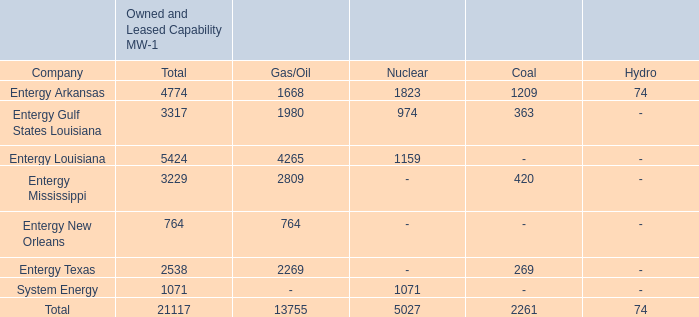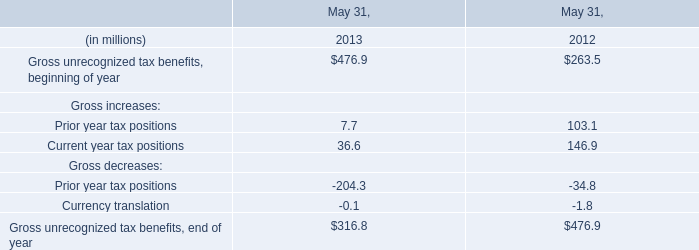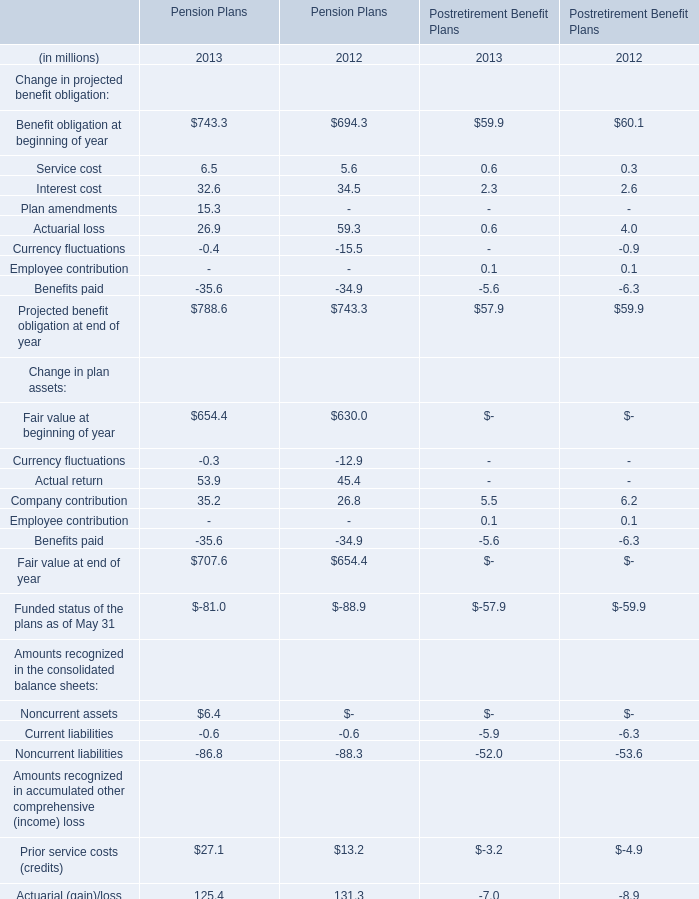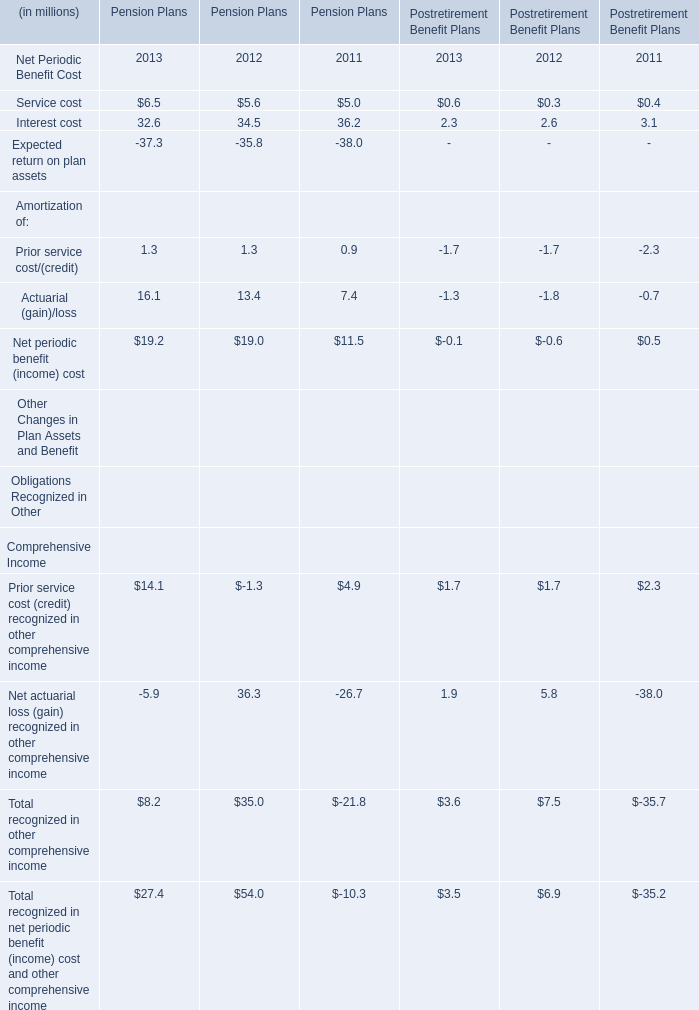In which years is Service cost greater than Expected return on plan assets for Pension Plans ? 
Answer: 2011 2012 2013. 